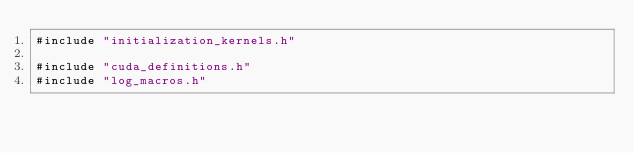Convert code to text. <code><loc_0><loc_0><loc_500><loc_500><_Cuda_>#include "initialization_kernels.h"

#include "cuda_definitions.h"
#include "log_macros.h"
</code> 